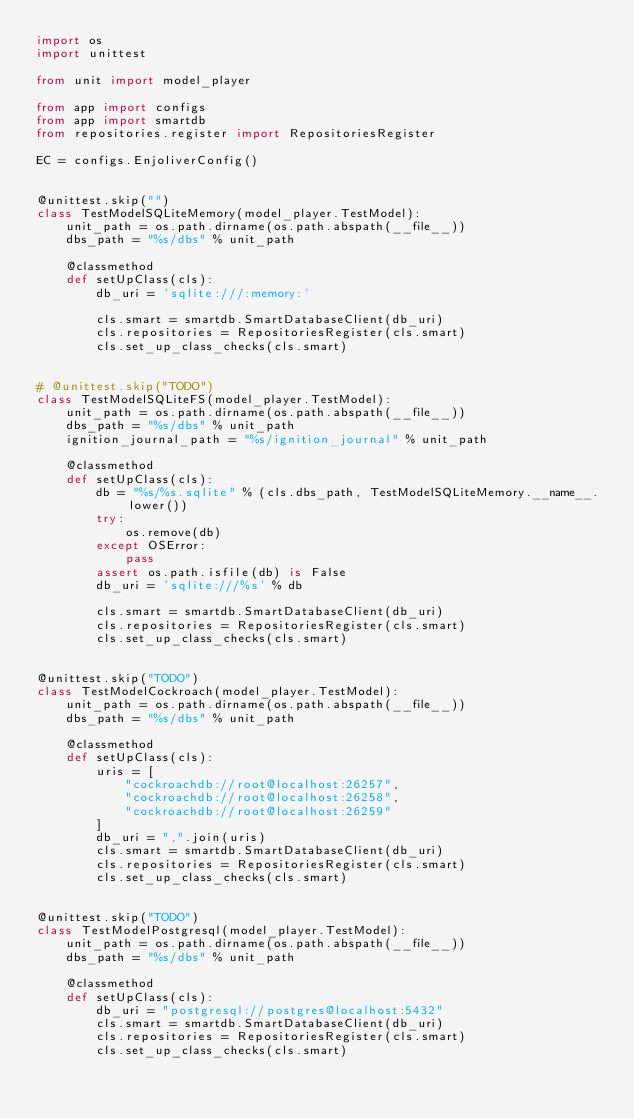Convert code to text. <code><loc_0><loc_0><loc_500><loc_500><_Python_>import os
import unittest

from unit import model_player

from app import configs
from app import smartdb
from repositories.register import RepositoriesRegister

EC = configs.EnjoliverConfig()


@unittest.skip("")
class TestModelSQLiteMemory(model_player.TestModel):
    unit_path = os.path.dirname(os.path.abspath(__file__))
    dbs_path = "%s/dbs" % unit_path

    @classmethod
    def setUpClass(cls):
        db_uri = 'sqlite:///:memory:'

        cls.smart = smartdb.SmartDatabaseClient(db_uri)
        cls.repositories = RepositoriesRegister(cls.smart)
        cls.set_up_class_checks(cls.smart)


# @unittest.skip("TODO")
class TestModelSQLiteFS(model_player.TestModel):
    unit_path = os.path.dirname(os.path.abspath(__file__))
    dbs_path = "%s/dbs" % unit_path
    ignition_journal_path = "%s/ignition_journal" % unit_path

    @classmethod
    def setUpClass(cls):
        db = "%s/%s.sqlite" % (cls.dbs_path, TestModelSQLiteMemory.__name__.lower())
        try:
            os.remove(db)
        except OSError:
            pass
        assert os.path.isfile(db) is False
        db_uri = 'sqlite:///%s' % db

        cls.smart = smartdb.SmartDatabaseClient(db_uri)
        cls.repositories = RepositoriesRegister(cls.smart)
        cls.set_up_class_checks(cls.smart)


@unittest.skip("TODO")
class TestModelCockroach(model_player.TestModel):
    unit_path = os.path.dirname(os.path.abspath(__file__))
    dbs_path = "%s/dbs" % unit_path

    @classmethod
    def setUpClass(cls):
        uris = [
            "cockroachdb://root@localhost:26257",
            "cockroachdb://root@localhost:26258",
            "cockroachdb://root@localhost:26259"
        ]
        db_uri = ",".join(uris)
        cls.smart = smartdb.SmartDatabaseClient(db_uri)
        cls.repositories = RepositoriesRegister(cls.smart)
        cls.set_up_class_checks(cls.smart)


@unittest.skip("TODO")
class TestModelPostgresql(model_player.TestModel):
    unit_path = os.path.dirname(os.path.abspath(__file__))
    dbs_path = "%s/dbs" % unit_path

    @classmethod
    def setUpClass(cls):
        db_uri = "postgresql://postgres@localhost:5432"
        cls.smart = smartdb.SmartDatabaseClient(db_uri)
        cls.repositories = RepositoriesRegister(cls.smart)
        cls.set_up_class_checks(cls.smart)
</code> 